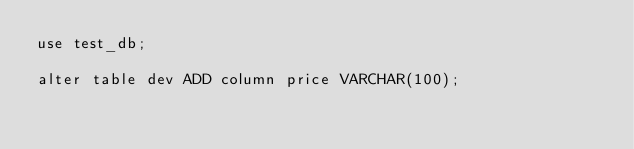<code> <loc_0><loc_0><loc_500><loc_500><_SQL_>use test_db;

alter table dev ADD column price VARCHAR(100);</code> 